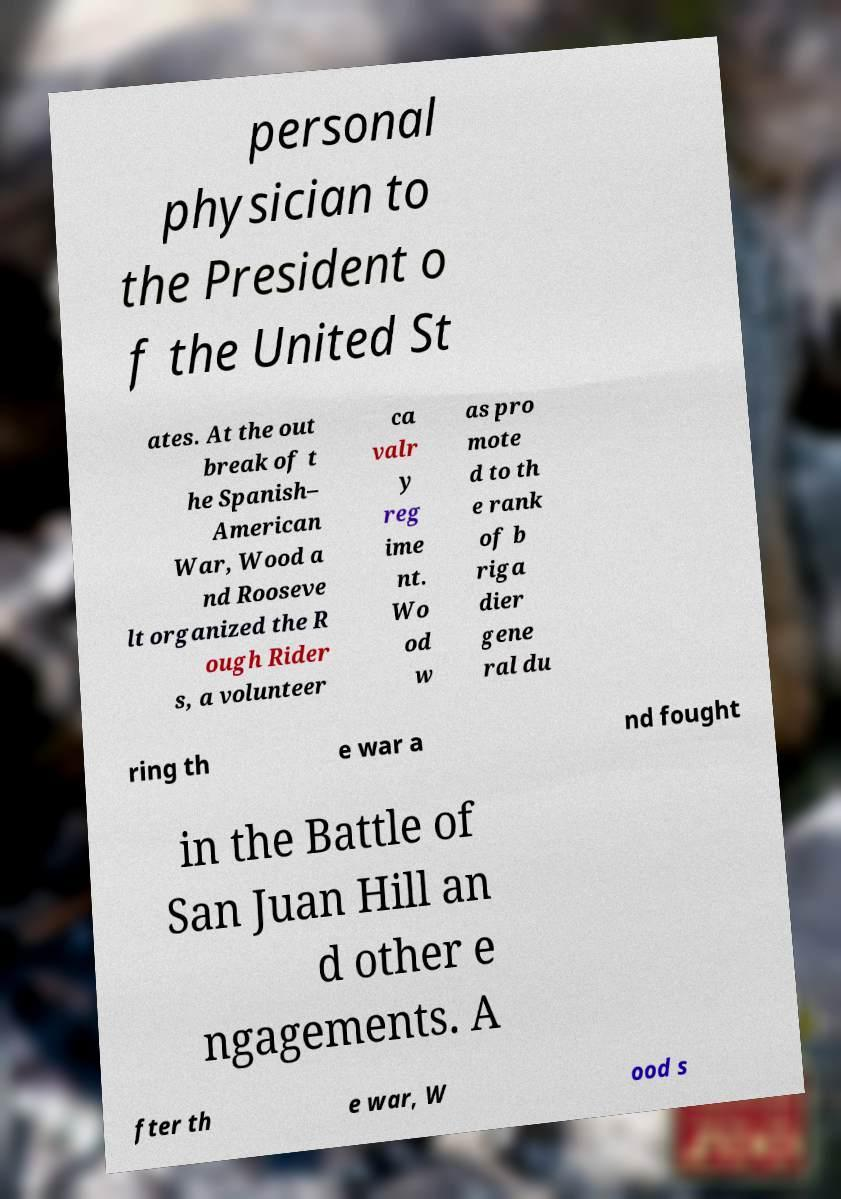For documentation purposes, I need the text within this image transcribed. Could you provide that? personal physician to the President o f the United St ates. At the out break of t he Spanish– American War, Wood a nd Rooseve lt organized the R ough Rider s, a volunteer ca valr y reg ime nt. Wo od w as pro mote d to th e rank of b riga dier gene ral du ring th e war a nd fought in the Battle of San Juan Hill an d other e ngagements. A fter th e war, W ood s 